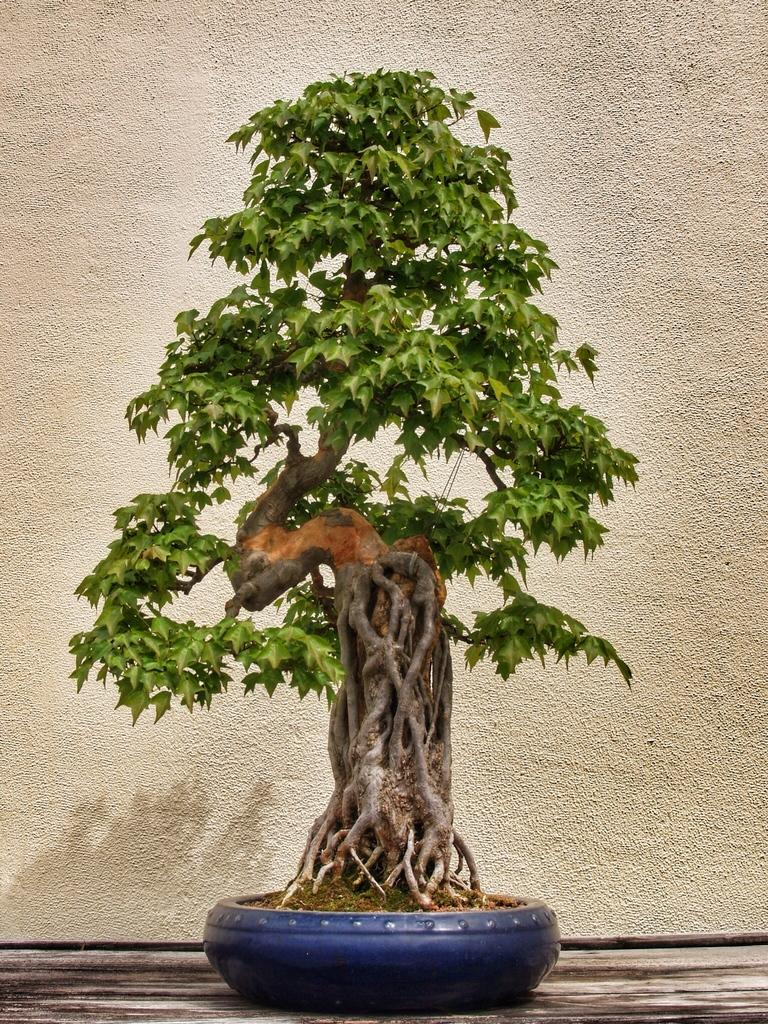What type of tree is in the blue pot in the image? There is a small tree in a blue color pot in the image. What material is the object at the bottom of the image made of? The object at the bottom of the image is made of wood. What can be seen in the background of the image? There is a wall in the background of the image. What color is the wall in the image? The wall is white in color. How many ladybugs are crawling on the small tree in the image? There are no ladybugs present in the image; it only features a small tree in a blue pot and a wooden object at the bottom. Is there a cabbage growing next to the small tree in the image? There is no cabbage present in the image; it only features a small tree in a blue pot and a wooden object at the bottom. 